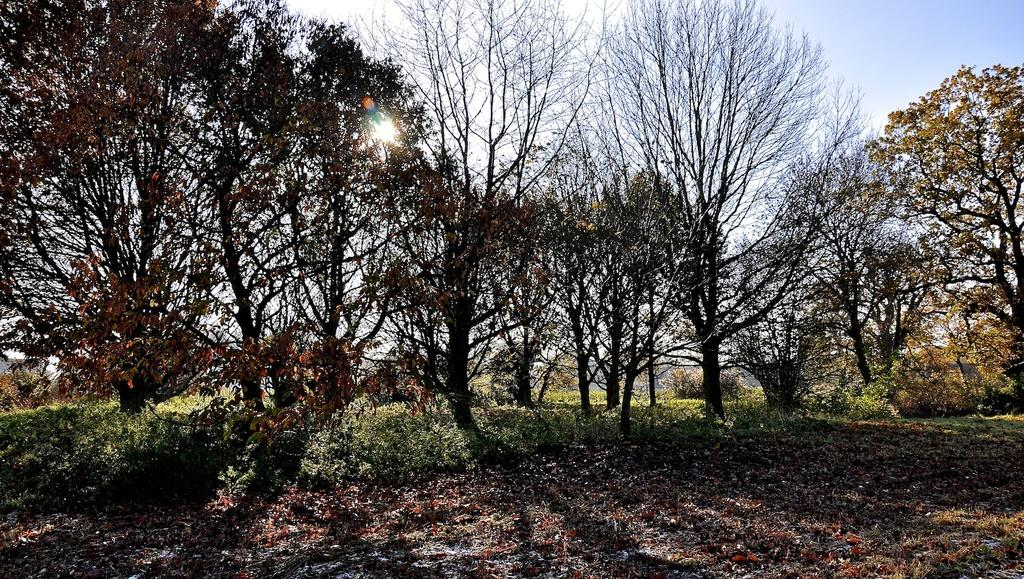What type of vegetation can be seen in the image? There are trees, grass, and plants in the image. What is visible in the background of the image? The sky is visible in the image. What is the condition of the sky in the image? The sky is clear in the image. Can the sun be seen in the image? Yes, the sun is visible in the image. What type of pain is the rock experiencing in the image? There is no rock present in the image, and therefore no pain can be attributed to it. 